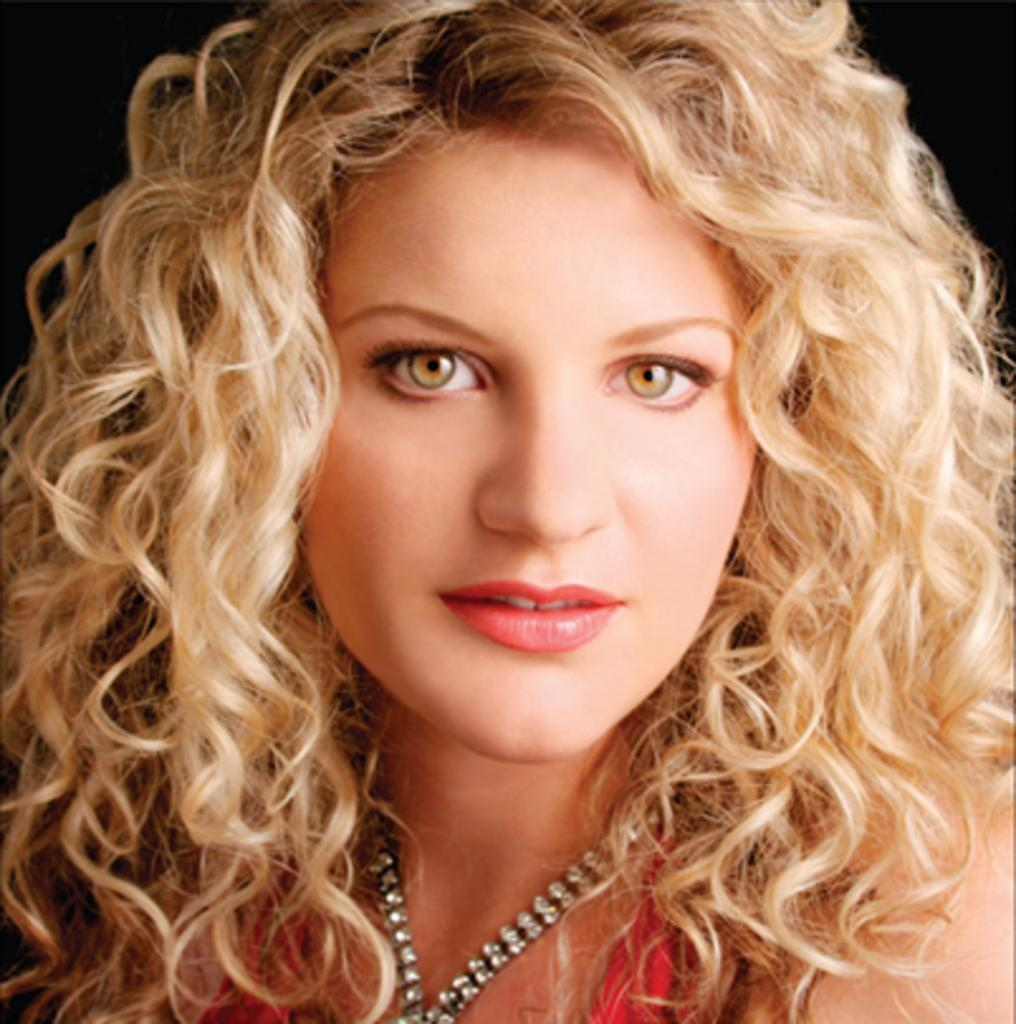Who is the main subject in the image? There is a woman in the image. What is a noticeable feature of the woman's appearance? The woman has brown hair. What can be observed about the background of the image? The background of the image is dark. What type of fork is the woman holding in the image? There is no fork present in the image. Can you tell me how many pickles are on the woman's plate in the image? There is no plate or pickles present in the image. 